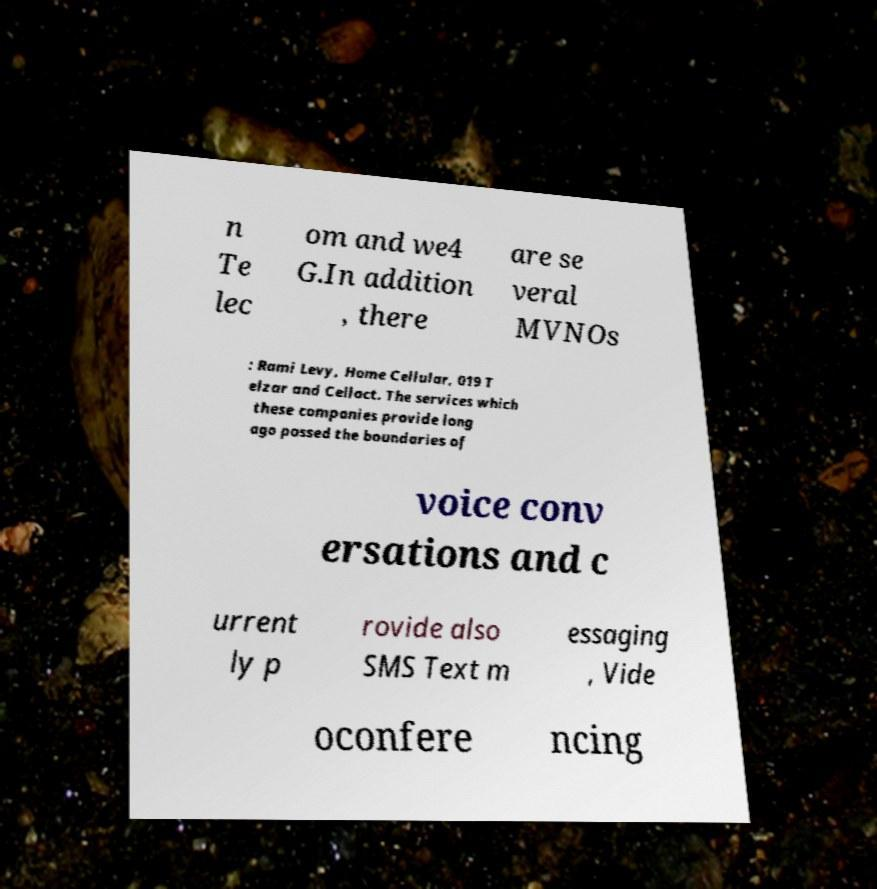Can you read and provide the text displayed in the image?This photo seems to have some interesting text. Can you extract and type it out for me? n Te lec om and we4 G.In addition , there are se veral MVNOs : Rami Levy, Home Cellular, 019 T elzar and Cellact. The services which these companies provide long ago passed the boundaries of voice conv ersations and c urrent ly p rovide also SMS Text m essaging , Vide oconfere ncing 